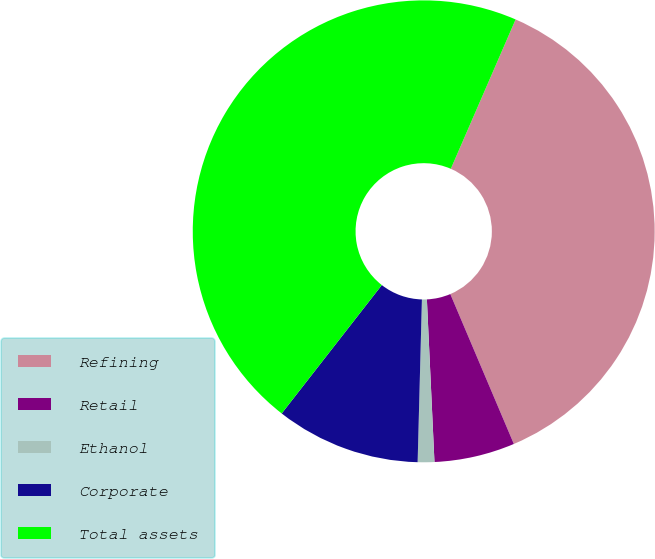Convert chart. <chart><loc_0><loc_0><loc_500><loc_500><pie_chart><fcel>Refining<fcel>Retail<fcel>Ethanol<fcel>Corporate<fcel>Total assets<nl><fcel>37.1%<fcel>5.64%<fcel>1.16%<fcel>10.12%<fcel>45.97%<nl></chart> 